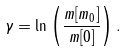<formula> <loc_0><loc_0><loc_500><loc_500>\gamma = \ln \left ( \frac { m [ m _ { 0 } ] } { m [ 0 ] } \right ) .</formula> 